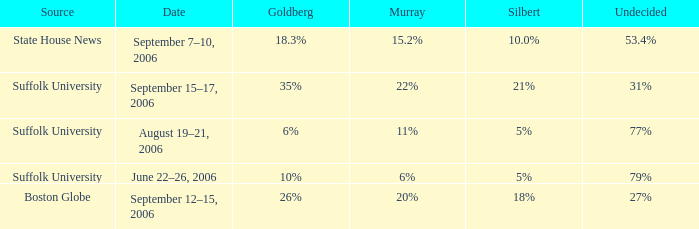What is the date of the poll with Goldberg at 26%? September 12–15, 2006. 